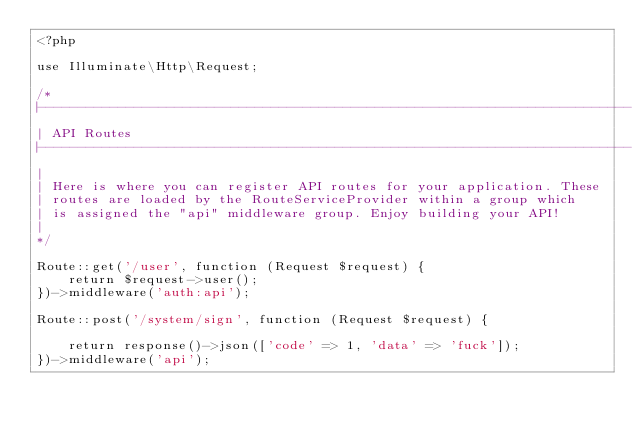<code> <loc_0><loc_0><loc_500><loc_500><_PHP_><?php

use Illuminate\Http\Request;

/*
|--------------------------------------------------------------------------
| API Routes
|--------------------------------------------------------------------------
|
| Here is where you can register API routes for your application. These
| routes are loaded by the RouteServiceProvider within a group which
| is assigned the "api" middleware group. Enjoy building your API!
|
*/

Route::get('/user', function (Request $request) {
    return $request->user();
})->middleware('auth:api');

Route::post('/system/sign', function (Request $request) {

    return response()->json(['code' => 1, 'data' => 'fuck']);
})->middleware('api');
</code> 